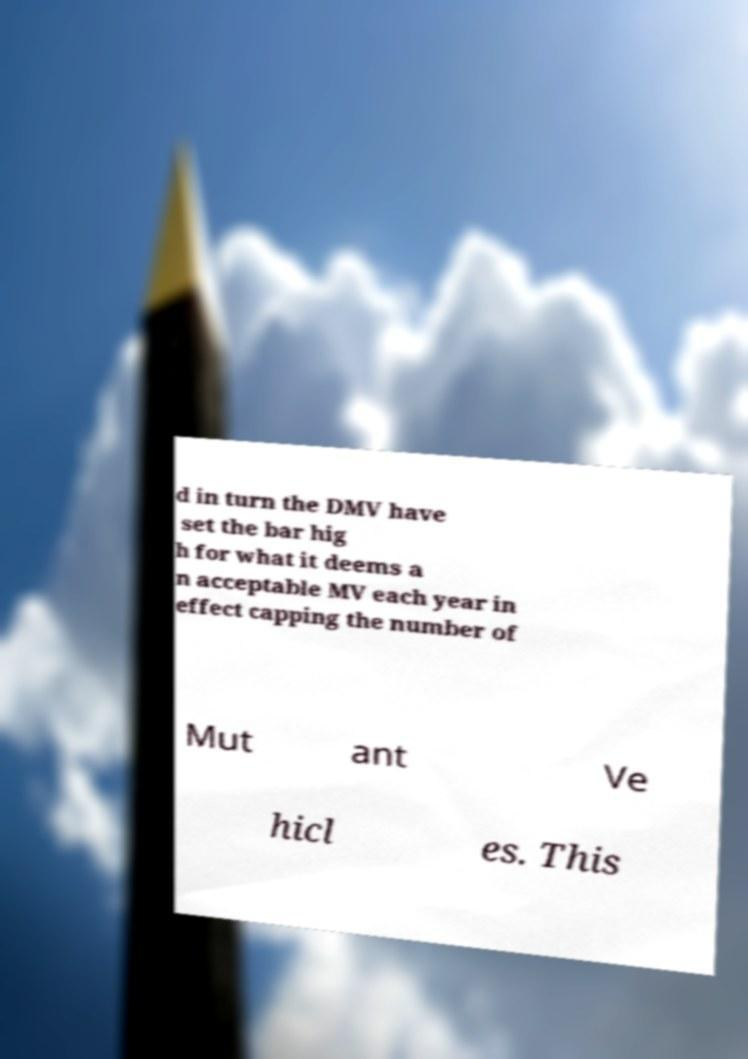What messages or text are displayed in this image? I need them in a readable, typed format. d in turn the DMV have set the bar hig h for what it deems a n acceptable MV each year in effect capping the number of Mut ant Ve hicl es. This 